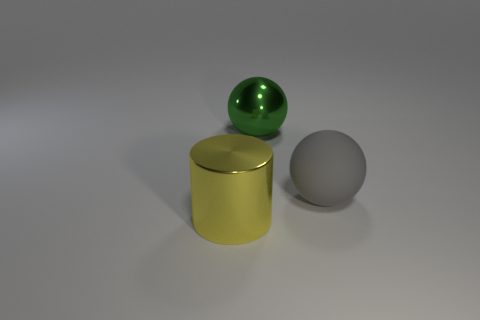There is a object that is to the left of the metal thing that is behind the yellow metallic cylinder; how many large shiny objects are behind it?
Provide a short and direct response. 1. What number of large things are both to the left of the large shiny ball and to the right of the cylinder?
Your answer should be compact. 0. Is the number of large yellow objects that are behind the yellow metallic object greater than the number of large matte objects?
Your answer should be very brief. No. What number of other gray cylinders have the same size as the cylinder?
Keep it short and to the point. 0. How many large things are blue metallic spheres or gray spheres?
Ensure brevity in your answer.  1. What number of big gray matte balls are there?
Your response must be concise. 1. Is the number of things on the right side of the big gray object the same as the number of large cylinders on the right side of the large green metallic thing?
Your answer should be compact. Yes. There is a big yellow metallic thing; are there any things behind it?
Keep it short and to the point. Yes. There is a large shiny thing that is on the right side of the big yellow cylinder; what color is it?
Provide a short and direct response. Green. What material is the ball on the left side of the ball that is right of the big green shiny thing?
Provide a short and direct response. Metal. 